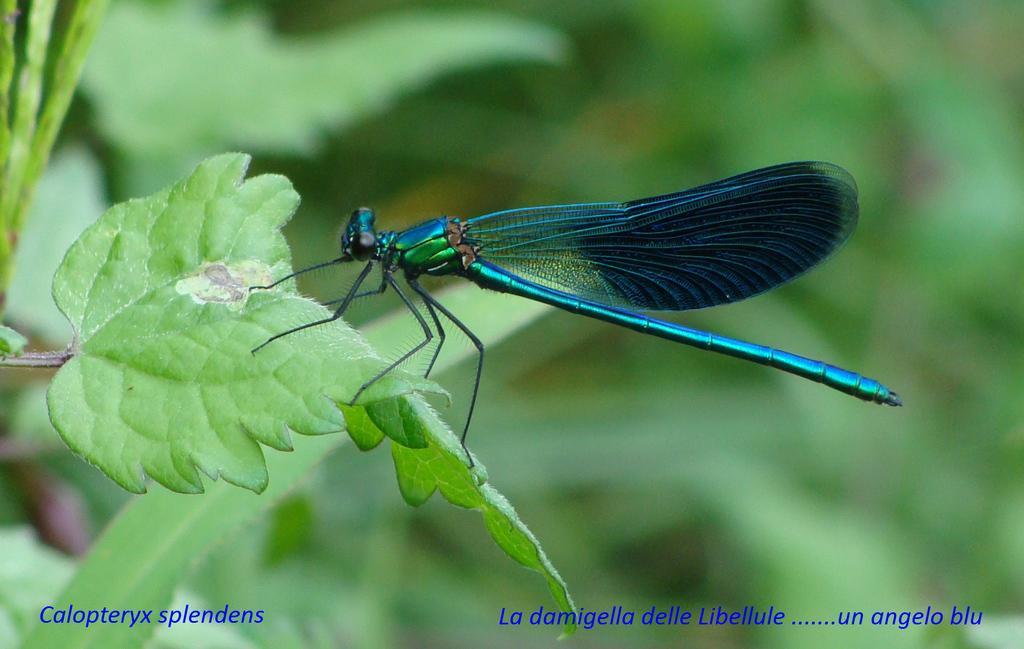Describe this image in one or two sentences. In this image there is a fly standing on the leaf. 